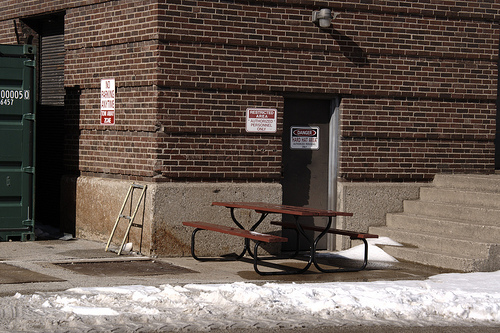<image>
Is there a ladder on the bench? No. The ladder is not positioned on the bench. They may be near each other, but the ladder is not supported by or resting on top of the bench. 